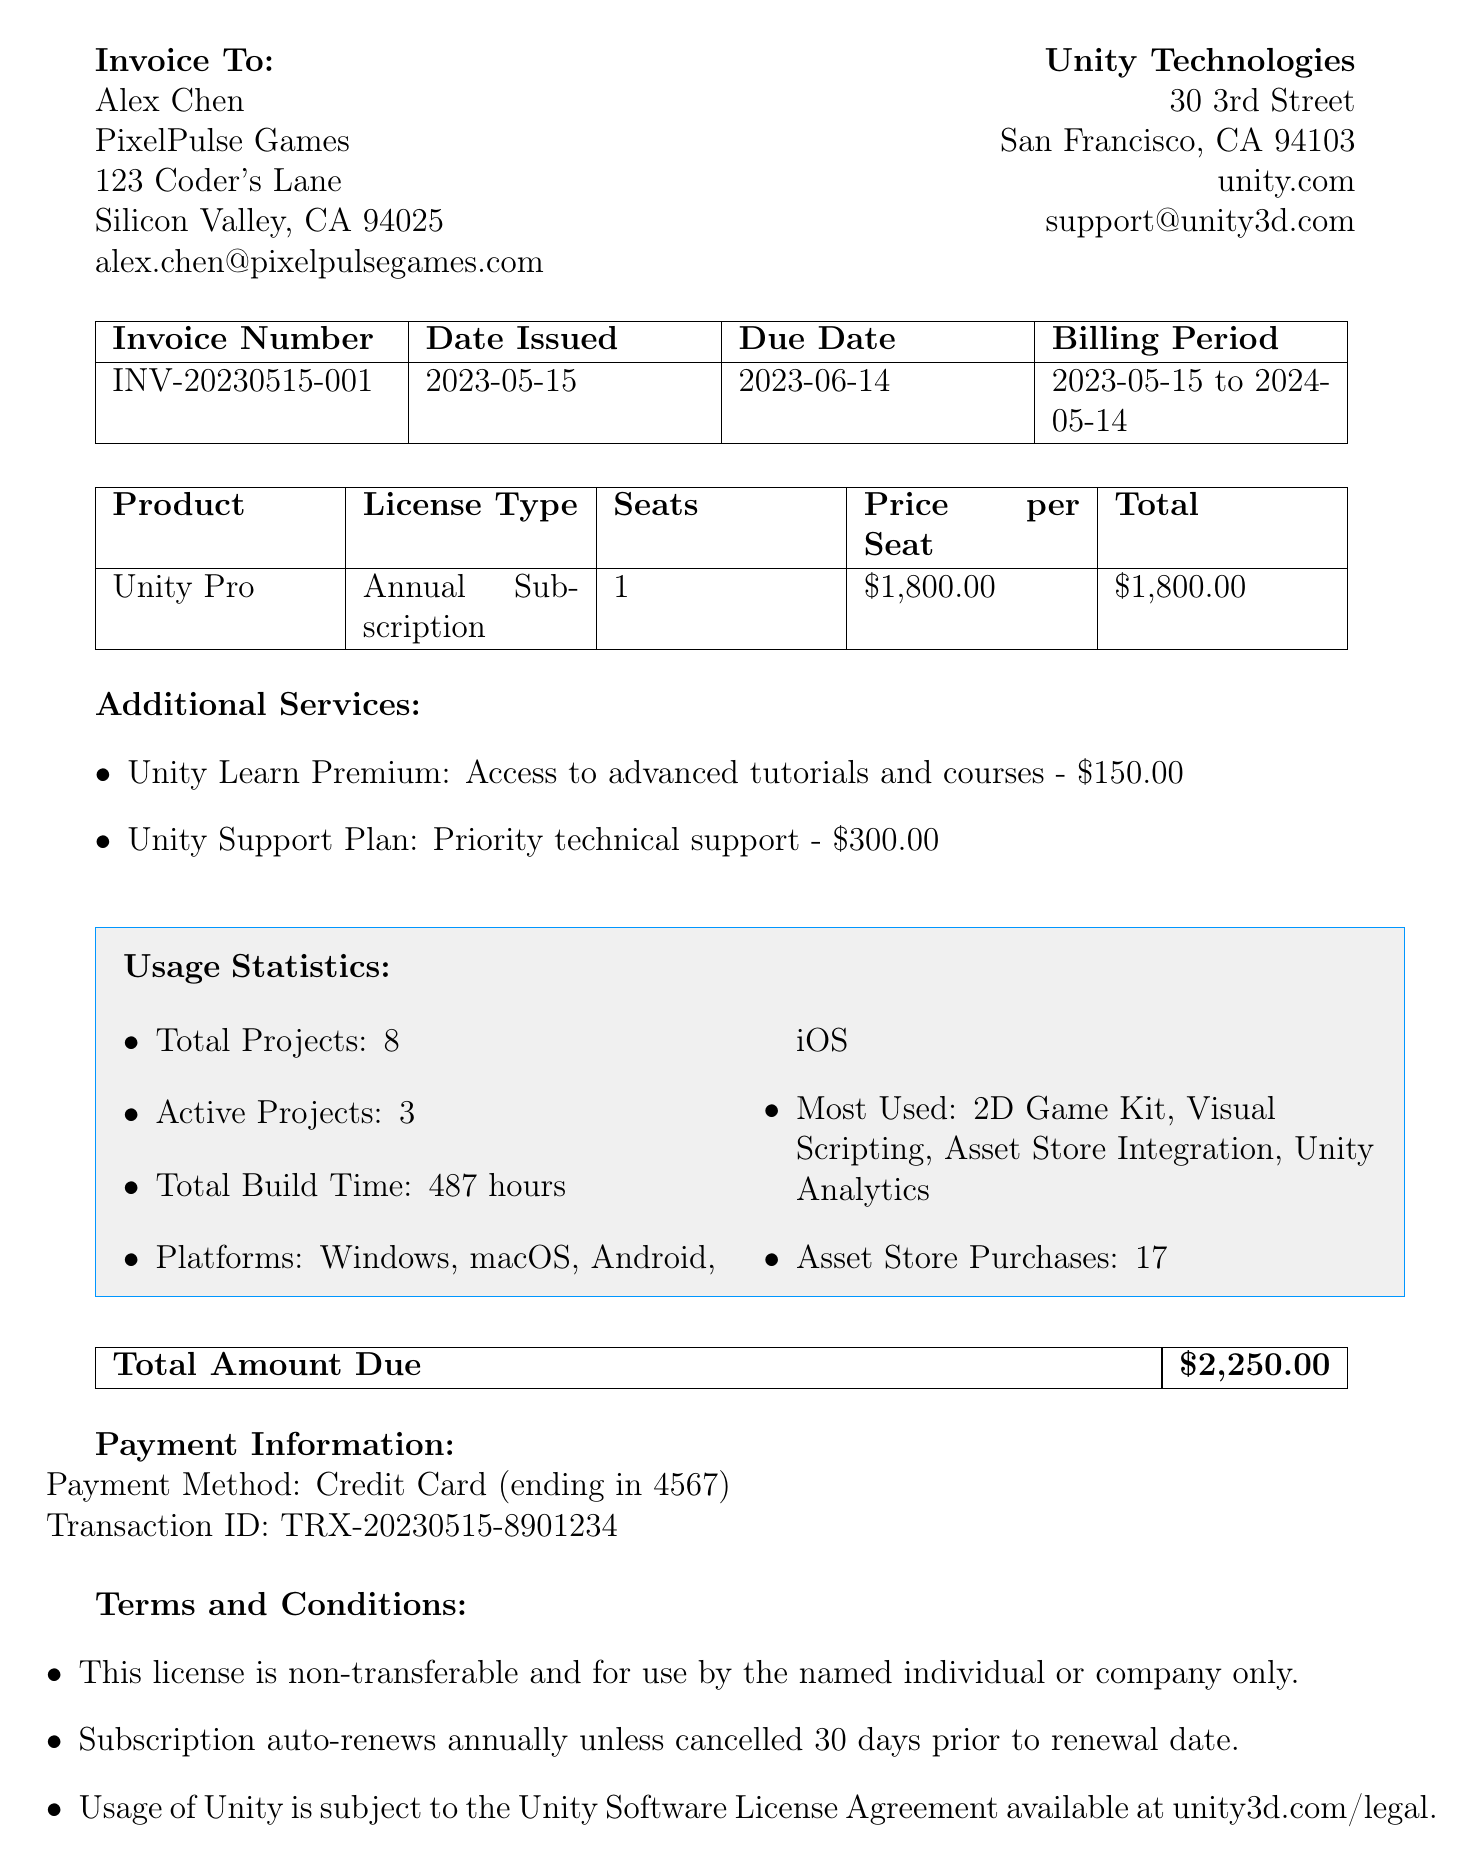What is the invoice number? The invoice number is a specific identifier for the transaction provided in the document, which is indicated as "INV-20230515-001".
Answer: INV-20230515-001 Who is the customer? The customer is the entity being billed for the services rendered, and is listed as "Alex Chen".
Answer: Alex Chen What is the total amount due? The total amount due represents the sum payable for the subscription services as shown in the document, which is "$2,250.00".
Answer: $2,250.00 How many active projects are there? The number of active projects represents the ongoing uses of the license, indicated in the usage statistics as "3".
Answer: 3 What is the price per seat? The price per seat is the specific charge for each license holder specified in the license details, which is "$1,800.00".
Answer: $1,800.00 What platforms was the software built for? The platforms built for indicate compatibility, listed in the usage statistics section as "Windows, macOS, Android, iOS".
Answer: Windows, macOS, Android, iOS What is the license type? The license type specifies the nature of the subscription under which the services are rendered, denoted as "Annual Subscription".
Answer: Annual Subscription When is the due date for payment? The due date is the final date by which the payment must be made, specified in the document as "2023-06-14".
Answer: 2023-06-14 What are the additional services offered? The additional services are extra options available for purchase, listed in the document as "Unity Learn Premium" and "Unity Support Plan".
Answer: Unity Learn Premium, Unity Support Plan 